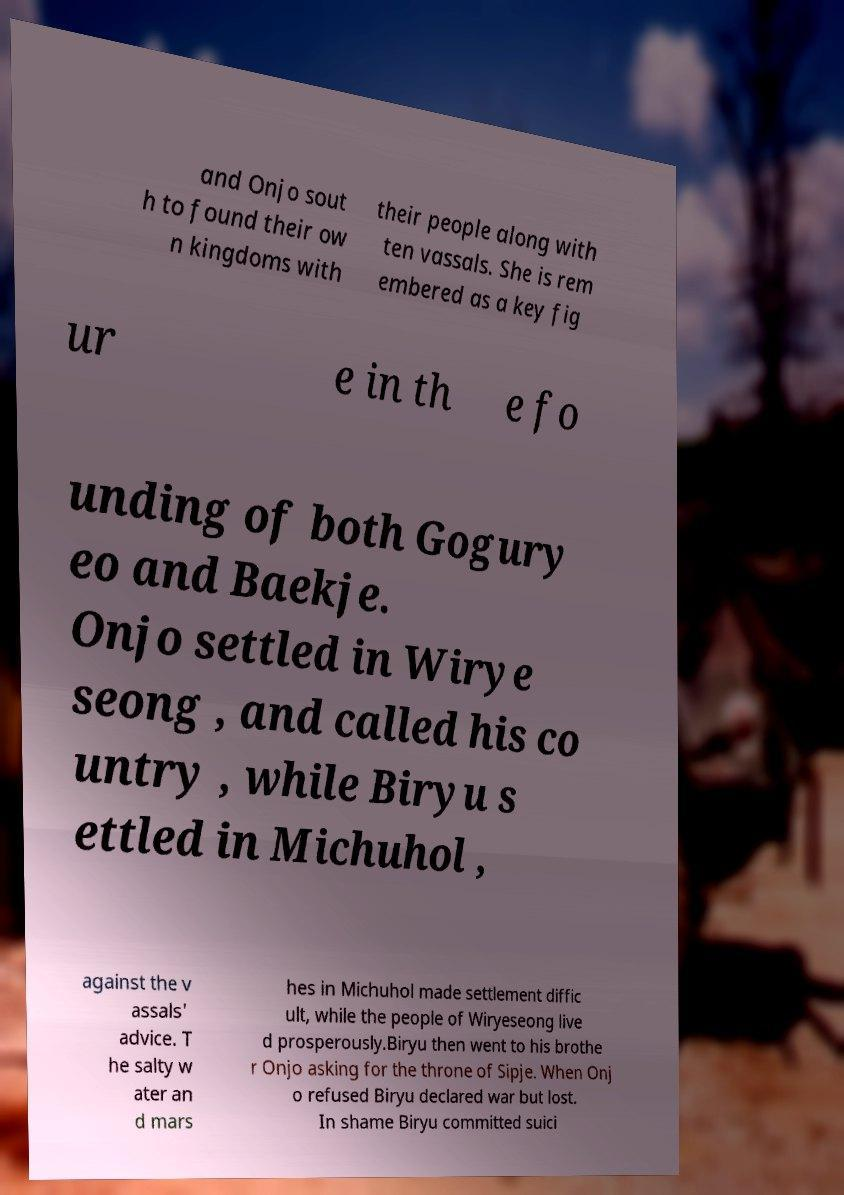For documentation purposes, I need the text within this image transcribed. Could you provide that? and Onjo sout h to found their ow n kingdoms with their people along with ten vassals. She is rem embered as a key fig ur e in th e fo unding of both Gogury eo and Baekje. Onjo settled in Wirye seong , and called his co untry , while Biryu s ettled in Michuhol , against the v assals' advice. T he salty w ater an d mars hes in Michuhol made settlement diffic ult, while the people of Wiryeseong live d prosperously.Biryu then went to his brothe r Onjo asking for the throne of Sipje. When Onj o refused Biryu declared war but lost. In shame Biryu committed suici 